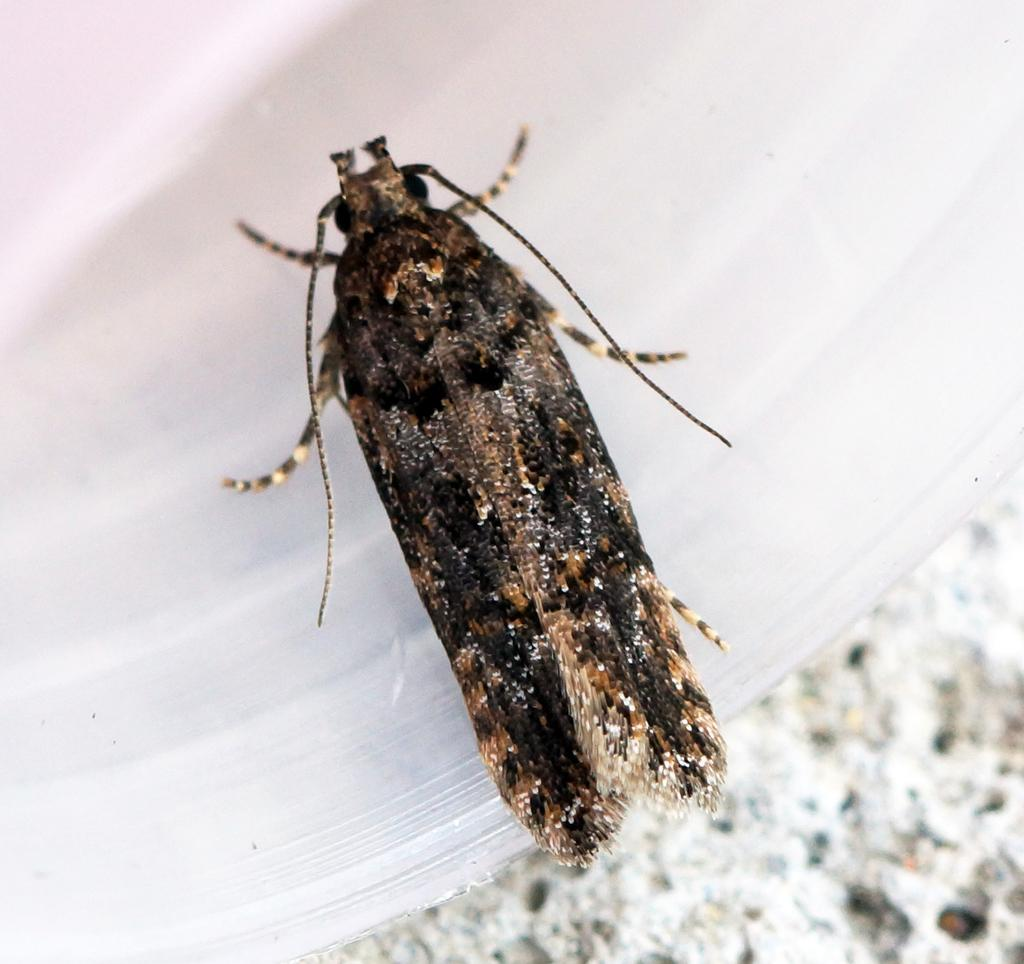What type of creature can be seen in the image? There is an insect in the image. What type of thread is the insect using to teach reading in the image? There is no thread, teaching, or reading present in the image; it only features an insect. 